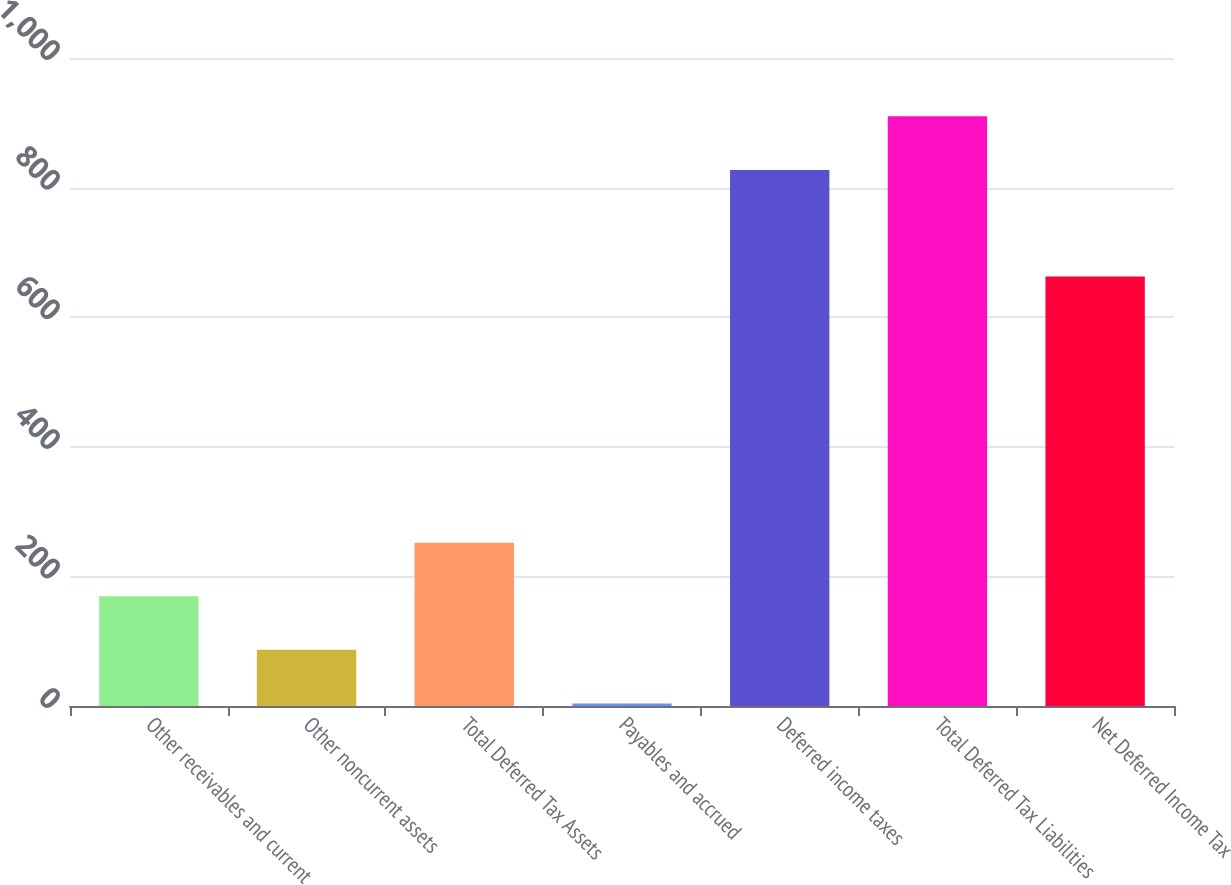Convert chart to OTSL. <chart><loc_0><loc_0><loc_500><loc_500><bar_chart><fcel>Other receivables and current<fcel>Other noncurrent assets<fcel>Total Deferred Tax Assets<fcel>Payables and accrued<fcel>Deferred income taxes<fcel>Total Deferred Tax Liabilities<fcel>Net Deferred Income Tax<nl><fcel>169.34<fcel>86.62<fcel>252.06<fcel>3.9<fcel>827.2<fcel>909.92<fcel>662.7<nl></chart> 